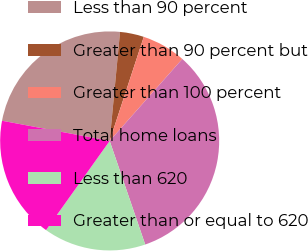<chart> <loc_0><loc_0><loc_500><loc_500><pie_chart><fcel>Less than 90 percent<fcel>Greater than 90 percent but<fcel>Greater than 100 percent<fcel>Total home loans<fcel>Less than 620<fcel>Greater than or equal to 620<nl><fcel>23.56%<fcel>3.53%<fcel>6.5%<fcel>33.2%<fcel>15.12%<fcel>18.09%<nl></chart> 